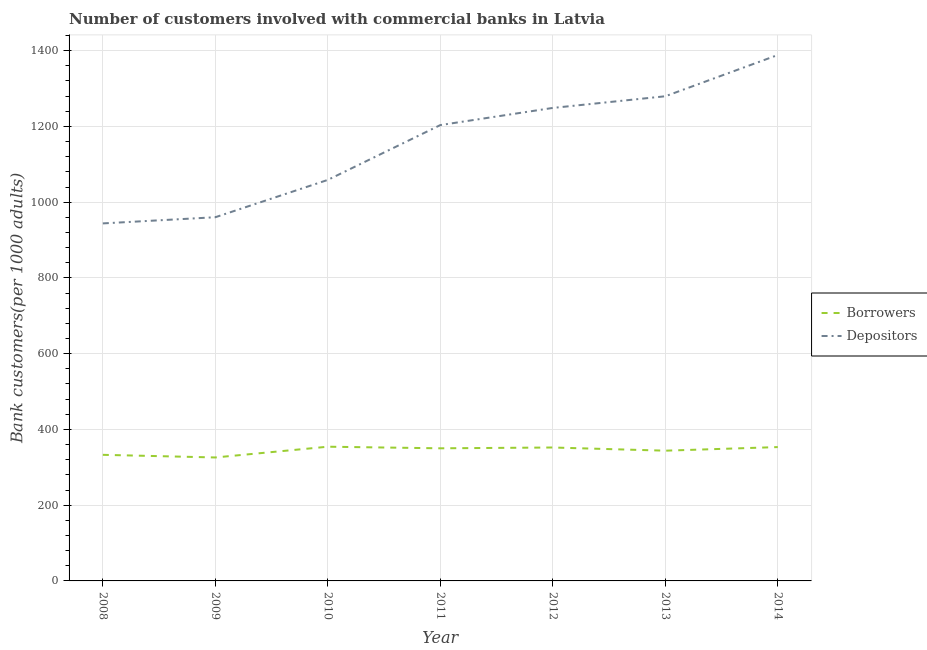Is the number of lines equal to the number of legend labels?
Provide a succinct answer. Yes. What is the number of depositors in 2010?
Make the answer very short. 1058.81. Across all years, what is the maximum number of borrowers?
Give a very brief answer. 354.36. Across all years, what is the minimum number of depositors?
Your answer should be very brief. 943.94. In which year was the number of depositors minimum?
Provide a short and direct response. 2008. What is the total number of depositors in the graph?
Your answer should be compact. 8083.57. What is the difference between the number of borrowers in 2013 and that in 2014?
Give a very brief answer. -9.52. What is the difference between the number of borrowers in 2012 and the number of depositors in 2013?
Your answer should be compact. -927.38. What is the average number of borrowers per year?
Offer a terse response. 344.7. In the year 2008, what is the difference between the number of borrowers and number of depositors?
Your response must be concise. -611.01. In how many years, is the number of borrowers greater than 680?
Provide a succinct answer. 0. What is the ratio of the number of depositors in 2008 to that in 2010?
Make the answer very short. 0.89. Is the number of borrowers in 2009 less than that in 2011?
Provide a succinct answer. Yes. Is the difference between the number of borrowers in 2010 and 2014 greater than the difference between the number of depositors in 2010 and 2014?
Offer a terse response. Yes. What is the difference between the highest and the second highest number of borrowers?
Make the answer very short. 0.97. What is the difference between the highest and the lowest number of depositors?
Offer a terse response. 444.63. In how many years, is the number of borrowers greater than the average number of borrowers taken over all years?
Your answer should be very brief. 4. Is the sum of the number of borrowers in 2011 and 2014 greater than the maximum number of depositors across all years?
Make the answer very short. No. Does the number of borrowers monotonically increase over the years?
Offer a very short reply. No. Is the number of borrowers strictly greater than the number of depositors over the years?
Ensure brevity in your answer.  No. Is the number of borrowers strictly less than the number of depositors over the years?
Provide a succinct answer. Yes. How many lines are there?
Make the answer very short. 2. How many years are there in the graph?
Ensure brevity in your answer.  7. What is the difference between two consecutive major ticks on the Y-axis?
Ensure brevity in your answer.  200. Are the values on the major ticks of Y-axis written in scientific E-notation?
Your response must be concise. No. Does the graph contain grids?
Offer a terse response. Yes. Where does the legend appear in the graph?
Ensure brevity in your answer.  Center right. How many legend labels are there?
Ensure brevity in your answer.  2. How are the legend labels stacked?
Keep it short and to the point. Vertical. What is the title of the graph?
Your answer should be very brief. Number of customers involved with commercial banks in Latvia. What is the label or title of the X-axis?
Offer a very short reply. Year. What is the label or title of the Y-axis?
Provide a short and direct response. Bank customers(per 1000 adults). What is the Bank customers(per 1000 adults) in Borrowers in 2008?
Make the answer very short. 332.93. What is the Bank customers(per 1000 adults) in Depositors in 2008?
Keep it short and to the point. 943.94. What is the Bank customers(per 1000 adults) of Borrowers in 2009?
Ensure brevity in your answer.  325.95. What is the Bank customers(per 1000 adults) of Depositors in 2009?
Provide a short and direct response. 960.24. What is the Bank customers(per 1000 adults) in Borrowers in 2010?
Your response must be concise. 354.36. What is the Bank customers(per 1000 adults) of Depositors in 2010?
Your answer should be very brief. 1058.81. What is the Bank customers(per 1000 adults) of Borrowers in 2011?
Your answer should be compact. 350.14. What is the Bank customers(per 1000 adults) in Depositors in 2011?
Your answer should be compact. 1203.54. What is the Bank customers(per 1000 adults) in Borrowers in 2012?
Provide a succinct answer. 352.26. What is the Bank customers(per 1000 adults) in Depositors in 2012?
Your answer should be very brief. 1248.84. What is the Bank customers(per 1000 adults) in Borrowers in 2013?
Your answer should be compact. 343.87. What is the Bank customers(per 1000 adults) in Depositors in 2013?
Your response must be concise. 1279.63. What is the Bank customers(per 1000 adults) of Borrowers in 2014?
Offer a very short reply. 353.39. What is the Bank customers(per 1000 adults) of Depositors in 2014?
Make the answer very short. 1388.57. Across all years, what is the maximum Bank customers(per 1000 adults) in Borrowers?
Your answer should be very brief. 354.36. Across all years, what is the maximum Bank customers(per 1000 adults) of Depositors?
Give a very brief answer. 1388.57. Across all years, what is the minimum Bank customers(per 1000 adults) in Borrowers?
Offer a terse response. 325.95. Across all years, what is the minimum Bank customers(per 1000 adults) of Depositors?
Keep it short and to the point. 943.94. What is the total Bank customers(per 1000 adults) of Borrowers in the graph?
Offer a very short reply. 2412.9. What is the total Bank customers(per 1000 adults) in Depositors in the graph?
Your answer should be compact. 8083.57. What is the difference between the Bank customers(per 1000 adults) in Borrowers in 2008 and that in 2009?
Provide a short and direct response. 6.98. What is the difference between the Bank customers(per 1000 adults) of Depositors in 2008 and that in 2009?
Offer a very short reply. -16.3. What is the difference between the Bank customers(per 1000 adults) in Borrowers in 2008 and that in 2010?
Your answer should be very brief. -21.43. What is the difference between the Bank customers(per 1000 adults) of Depositors in 2008 and that in 2010?
Your answer should be compact. -114.87. What is the difference between the Bank customers(per 1000 adults) in Borrowers in 2008 and that in 2011?
Provide a short and direct response. -17.21. What is the difference between the Bank customers(per 1000 adults) of Depositors in 2008 and that in 2011?
Offer a terse response. -259.6. What is the difference between the Bank customers(per 1000 adults) in Borrowers in 2008 and that in 2012?
Offer a terse response. -19.32. What is the difference between the Bank customers(per 1000 adults) of Depositors in 2008 and that in 2012?
Provide a succinct answer. -304.9. What is the difference between the Bank customers(per 1000 adults) in Borrowers in 2008 and that in 2013?
Keep it short and to the point. -10.93. What is the difference between the Bank customers(per 1000 adults) of Depositors in 2008 and that in 2013?
Your answer should be very brief. -335.69. What is the difference between the Bank customers(per 1000 adults) of Borrowers in 2008 and that in 2014?
Offer a very short reply. -20.46. What is the difference between the Bank customers(per 1000 adults) in Depositors in 2008 and that in 2014?
Make the answer very short. -444.63. What is the difference between the Bank customers(per 1000 adults) of Borrowers in 2009 and that in 2010?
Make the answer very short. -28.41. What is the difference between the Bank customers(per 1000 adults) in Depositors in 2009 and that in 2010?
Your answer should be compact. -98.57. What is the difference between the Bank customers(per 1000 adults) of Borrowers in 2009 and that in 2011?
Ensure brevity in your answer.  -24.19. What is the difference between the Bank customers(per 1000 adults) of Depositors in 2009 and that in 2011?
Your answer should be very brief. -243.3. What is the difference between the Bank customers(per 1000 adults) of Borrowers in 2009 and that in 2012?
Keep it short and to the point. -26.3. What is the difference between the Bank customers(per 1000 adults) of Depositors in 2009 and that in 2012?
Your answer should be compact. -288.6. What is the difference between the Bank customers(per 1000 adults) in Borrowers in 2009 and that in 2013?
Make the answer very short. -17.92. What is the difference between the Bank customers(per 1000 adults) in Depositors in 2009 and that in 2013?
Offer a very short reply. -319.4. What is the difference between the Bank customers(per 1000 adults) in Borrowers in 2009 and that in 2014?
Offer a terse response. -27.44. What is the difference between the Bank customers(per 1000 adults) in Depositors in 2009 and that in 2014?
Your answer should be very brief. -428.33. What is the difference between the Bank customers(per 1000 adults) in Borrowers in 2010 and that in 2011?
Keep it short and to the point. 4.22. What is the difference between the Bank customers(per 1000 adults) in Depositors in 2010 and that in 2011?
Offer a terse response. -144.73. What is the difference between the Bank customers(per 1000 adults) in Borrowers in 2010 and that in 2012?
Ensure brevity in your answer.  2.11. What is the difference between the Bank customers(per 1000 adults) of Depositors in 2010 and that in 2012?
Your answer should be very brief. -190.03. What is the difference between the Bank customers(per 1000 adults) in Borrowers in 2010 and that in 2013?
Provide a succinct answer. 10.49. What is the difference between the Bank customers(per 1000 adults) of Depositors in 2010 and that in 2013?
Give a very brief answer. -220.82. What is the difference between the Bank customers(per 1000 adults) of Borrowers in 2010 and that in 2014?
Give a very brief answer. 0.97. What is the difference between the Bank customers(per 1000 adults) in Depositors in 2010 and that in 2014?
Your response must be concise. -329.76. What is the difference between the Bank customers(per 1000 adults) in Borrowers in 2011 and that in 2012?
Give a very brief answer. -2.12. What is the difference between the Bank customers(per 1000 adults) of Depositors in 2011 and that in 2012?
Provide a short and direct response. -45.3. What is the difference between the Bank customers(per 1000 adults) in Borrowers in 2011 and that in 2013?
Your answer should be very brief. 6.27. What is the difference between the Bank customers(per 1000 adults) of Depositors in 2011 and that in 2013?
Give a very brief answer. -76.09. What is the difference between the Bank customers(per 1000 adults) of Borrowers in 2011 and that in 2014?
Give a very brief answer. -3.25. What is the difference between the Bank customers(per 1000 adults) of Depositors in 2011 and that in 2014?
Make the answer very short. -185.03. What is the difference between the Bank customers(per 1000 adults) in Borrowers in 2012 and that in 2013?
Your answer should be very brief. 8.39. What is the difference between the Bank customers(per 1000 adults) of Depositors in 2012 and that in 2013?
Give a very brief answer. -30.79. What is the difference between the Bank customers(per 1000 adults) in Borrowers in 2012 and that in 2014?
Give a very brief answer. -1.13. What is the difference between the Bank customers(per 1000 adults) of Depositors in 2012 and that in 2014?
Your answer should be very brief. -139.73. What is the difference between the Bank customers(per 1000 adults) of Borrowers in 2013 and that in 2014?
Your response must be concise. -9.52. What is the difference between the Bank customers(per 1000 adults) of Depositors in 2013 and that in 2014?
Give a very brief answer. -108.93. What is the difference between the Bank customers(per 1000 adults) in Borrowers in 2008 and the Bank customers(per 1000 adults) in Depositors in 2009?
Ensure brevity in your answer.  -627.31. What is the difference between the Bank customers(per 1000 adults) in Borrowers in 2008 and the Bank customers(per 1000 adults) in Depositors in 2010?
Your response must be concise. -725.88. What is the difference between the Bank customers(per 1000 adults) in Borrowers in 2008 and the Bank customers(per 1000 adults) in Depositors in 2011?
Give a very brief answer. -870.61. What is the difference between the Bank customers(per 1000 adults) in Borrowers in 2008 and the Bank customers(per 1000 adults) in Depositors in 2012?
Ensure brevity in your answer.  -915.91. What is the difference between the Bank customers(per 1000 adults) of Borrowers in 2008 and the Bank customers(per 1000 adults) of Depositors in 2013?
Your answer should be very brief. -946.7. What is the difference between the Bank customers(per 1000 adults) of Borrowers in 2008 and the Bank customers(per 1000 adults) of Depositors in 2014?
Provide a succinct answer. -1055.63. What is the difference between the Bank customers(per 1000 adults) of Borrowers in 2009 and the Bank customers(per 1000 adults) of Depositors in 2010?
Keep it short and to the point. -732.86. What is the difference between the Bank customers(per 1000 adults) of Borrowers in 2009 and the Bank customers(per 1000 adults) of Depositors in 2011?
Give a very brief answer. -877.59. What is the difference between the Bank customers(per 1000 adults) in Borrowers in 2009 and the Bank customers(per 1000 adults) in Depositors in 2012?
Make the answer very short. -922.89. What is the difference between the Bank customers(per 1000 adults) in Borrowers in 2009 and the Bank customers(per 1000 adults) in Depositors in 2013?
Keep it short and to the point. -953.68. What is the difference between the Bank customers(per 1000 adults) in Borrowers in 2009 and the Bank customers(per 1000 adults) in Depositors in 2014?
Your answer should be very brief. -1062.62. What is the difference between the Bank customers(per 1000 adults) in Borrowers in 2010 and the Bank customers(per 1000 adults) in Depositors in 2011?
Your response must be concise. -849.18. What is the difference between the Bank customers(per 1000 adults) of Borrowers in 2010 and the Bank customers(per 1000 adults) of Depositors in 2012?
Your answer should be compact. -894.48. What is the difference between the Bank customers(per 1000 adults) in Borrowers in 2010 and the Bank customers(per 1000 adults) in Depositors in 2013?
Ensure brevity in your answer.  -925.27. What is the difference between the Bank customers(per 1000 adults) in Borrowers in 2010 and the Bank customers(per 1000 adults) in Depositors in 2014?
Ensure brevity in your answer.  -1034.21. What is the difference between the Bank customers(per 1000 adults) in Borrowers in 2011 and the Bank customers(per 1000 adults) in Depositors in 2012?
Make the answer very short. -898.7. What is the difference between the Bank customers(per 1000 adults) of Borrowers in 2011 and the Bank customers(per 1000 adults) of Depositors in 2013?
Ensure brevity in your answer.  -929.5. What is the difference between the Bank customers(per 1000 adults) in Borrowers in 2011 and the Bank customers(per 1000 adults) in Depositors in 2014?
Your answer should be compact. -1038.43. What is the difference between the Bank customers(per 1000 adults) in Borrowers in 2012 and the Bank customers(per 1000 adults) in Depositors in 2013?
Provide a short and direct response. -927.38. What is the difference between the Bank customers(per 1000 adults) of Borrowers in 2012 and the Bank customers(per 1000 adults) of Depositors in 2014?
Offer a terse response. -1036.31. What is the difference between the Bank customers(per 1000 adults) of Borrowers in 2013 and the Bank customers(per 1000 adults) of Depositors in 2014?
Give a very brief answer. -1044.7. What is the average Bank customers(per 1000 adults) of Borrowers per year?
Your answer should be very brief. 344.7. What is the average Bank customers(per 1000 adults) in Depositors per year?
Your response must be concise. 1154.8. In the year 2008, what is the difference between the Bank customers(per 1000 adults) of Borrowers and Bank customers(per 1000 adults) of Depositors?
Your answer should be very brief. -611.01. In the year 2009, what is the difference between the Bank customers(per 1000 adults) in Borrowers and Bank customers(per 1000 adults) in Depositors?
Offer a very short reply. -634.29. In the year 2010, what is the difference between the Bank customers(per 1000 adults) of Borrowers and Bank customers(per 1000 adults) of Depositors?
Give a very brief answer. -704.45. In the year 2011, what is the difference between the Bank customers(per 1000 adults) in Borrowers and Bank customers(per 1000 adults) in Depositors?
Your answer should be compact. -853.4. In the year 2012, what is the difference between the Bank customers(per 1000 adults) in Borrowers and Bank customers(per 1000 adults) in Depositors?
Ensure brevity in your answer.  -896.58. In the year 2013, what is the difference between the Bank customers(per 1000 adults) in Borrowers and Bank customers(per 1000 adults) in Depositors?
Your answer should be very brief. -935.77. In the year 2014, what is the difference between the Bank customers(per 1000 adults) of Borrowers and Bank customers(per 1000 adults) of Depositors?
Offer a terse response. -1035.18. What is the ratio of the Bank customers(per 1000 adults) in Borrowers in 2008 to that in 2009?
Your response must be concise. 1.02. What is the ratio of the Bank customers(per 1000 adults) in Borrowers in 2008 to that in 2010?
Offer a very short reply. 0.94. What is the ratio of the Bank customers(per 1000 adults) in Depositors in 2008 to that in 2010?
Ensure brevity in your answer.  0.89. What is the ratio of the Bank customers(per 1000 adults) in Borrowers in 2008 to that in 2011?
Your response must be concise. 0.95. What is the ratio of the Bank customers(per 1000 adults) of Depositors in 2008 to that in 2011?
Make the answer very short. 0.78. What is the ratio of the Bank customers(per 1000 adults) of Borrowers in 2008 to that in 2012?
Make the answer very short. 0.95. What is the ratio of the Bank customers(per 1000 adults) in Depositors in 2008 to that in 2012?
Provide a succinct answer. 0.76. What is the ratio of the Bank customers(per 1000 adults) of Borrowers in 2008 to that in 2013?
Ensure brevity in your answer.  0.97. What is the ratio of the Bank customers(per 1000 adults) in Depositors in 2008 to that in 2013?
Give a very brief answer. 0.74. What is the ratio of the Bank customers(per 1000 adults) in Borrowers in 2008 to that in 2014?
Give a very brief answer. 0.94. What is the ratio of the Bank customers(per 1000 adults) of Depositors in 2008 to that in 2014?
Your answer should be compact. 0.68. What is the ratio of the Bank customers(per 1000 adults) of Borrowers in 2009 to that in 2010?
Offer a very short reply. 0.92. What is the ratio of the Bank customers(per 1000 adults) of Depositors in 2009 to that in 2010?
Offer a very short reply. 0.91. What is the ratio of the Bank customers(per 1000 adults) of Borrowers in 2009 to that in 2011?
Provide a succinct answer. 0.93. What is the ratio of the Bank customers(per 1000 adults) of Depositors in 2009 to that in 2011?
Ensure brevity in your answer.  0.8. What is the ratio of the Bank customers(per 1000 adults) in Borrowers in 2009 to that in 2012?
Make the answer very short. 0.93. What is the ratio of the Bank customers(per 1000 adults) of Depositors in 2009 to that in 2012?
Provide a short and direct response. 0.77. What is the ratio of the Bank customers(per 1000 adults) in Borrowers in 2009 to that in 2013?
Provide a succinct answer. 0.95. What is the ratio of the Bank customers(per 1000 adults) in Depositors in 2009 to that in 2013?
Your answer should be very brief. 0.75. What is the ratio of the Bank customers(per 1000 adults) in Borrowers in 2009 to that in 2014?
Give a very brief answer. 0.92. What is the ratio of the Bank customers(per 1000 adults) in Depositors in 2009 to that in 2014?
Provide a succinct answer. 0.69. What is the ratio of the Bank customers(per 1000 adults) of Borrowers in 2010 to that in 2011?
Offer a terse response. 1.01. What is the ratio of the Bank customers(per 1000 adults) in Depositors in 2010 to that in 2011?
Make the answer very short. 0.88. What is the ratio of the Bank customers(per 1000 adults) in Depositors in 2010 to that in 2012?
Offer a terse response. 0.85. What is the ratio of the Bank customers(per 1000 adults) of Borrowers in 2010 to that in 2013?
Provide a succinct answer. 1.03. What is the ratio of the Bank customers(per 1000 adults) of Depositors in 2010 to that in 2013?
Provide a short and direct response. 0.83. What is the ratio of the Bank customers(per 1000 adults) of Borrowers in 2010 to that in 2014?
Offer a terse response. 1. What is the ratio of the Bank customers(per 1000 adults) in Depositors in 2010 to that in 2014?
Your answer should be very brief. 0.76. What is the ratio of the Bank customers(per 1000 adults) in Depositors in 2011 to that in 2012?
Provide a short and direct response. 0.96. What is the ratio of the Bank customers(per 1000 adults) of Borrowers in 2011 to that in 2013?
Ensure brevity in your answer.  1.02. What is the ratio of the Bank customers(per 1000 adults) of Depositors in 2011 to that in 2013?
Provide a short and direct response. 0.94. What is the ratio of the Bank customers(per 1000 adults) in Depositors in 2011 to that in 2014?
Your answer should be very brief. 0.87. What is the ratio of the Bank customers(per 1000 adults) of Borrowers in 2012 to that in 2013?
Your answer should be compact. 1.02. What is the ratio of the Bank customers(per 1000 adults) of Depositors in 2012 to that in 2013?
Keep it short and to the point. 0.98. What is the ratio of the Bank customers(per 1000 adults) in Depositors in 2012 to that in 2014?
Your response must be concise. 0.9. What is the ratio of the Bank customers(per 1000 adults) in Borrowers in 2013 to that in 2014?
Keep it short and to the point. 0.97. What is the ratio of the Bank customers(per 1000 adults) of Depositors in 2013 to that in 2014?
Ensure brevity in your answer.  0.92. What is the difference between the highest and the second highest Bank customers(per 1000 adults) in Borrowers?
Your answer should be very brief. 0.97. What is the difference between the highest and the second highest Bank customers(per 1000 adults) of Depositors?
Give a very brief answer. 108.93. What is the difference between the highest and the lowest Bank customers(per 1000 adults) of Borrowers?
Your answer should be compact. 28.41. What is the difference between the highest and the lowest Bank customers(per 1000 adults) in Depositors?
Offer a very short reply. 444.63. 